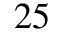Convert formula to latex. <formula><loc_0><loc_0><loc_500><loc_500>2 5</formula> 